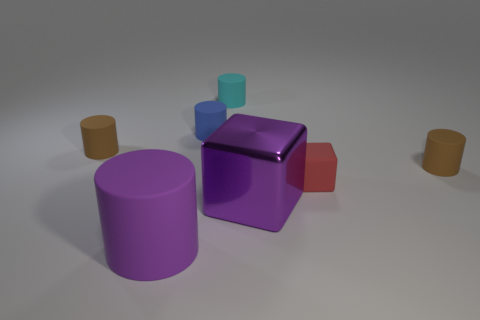Subtract 1 cylinders. How many cylinders are left? 4 Subtract all red cylinders. Subtract all blue spheres. How many cylinders are left? 5 Add 3 small rubber things. How many objects exist? 10 Subtract all blocks. How many objects are left? 5 Add 3 big rubber cylinders. How many big rubber cylinders are left? 4 Add 3 small blue rubber balls. How many small blue rubber balls exist? 3 Subtract 0 green spheres. How many objects are left? 7 Subtract all cubes. Subtract all small red rubber objects. How many objects are left? 4 